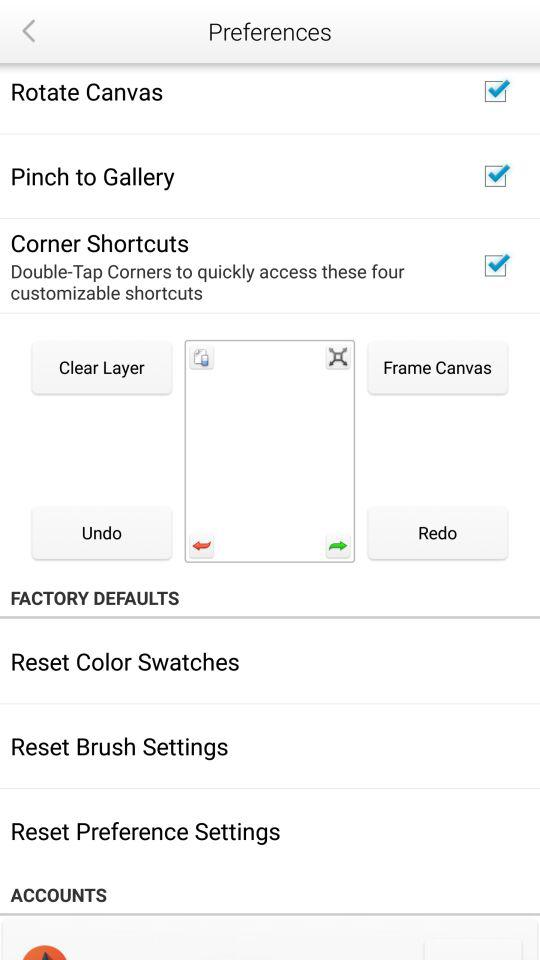What is the status of "Rotate Canvas"? The status is "on". 